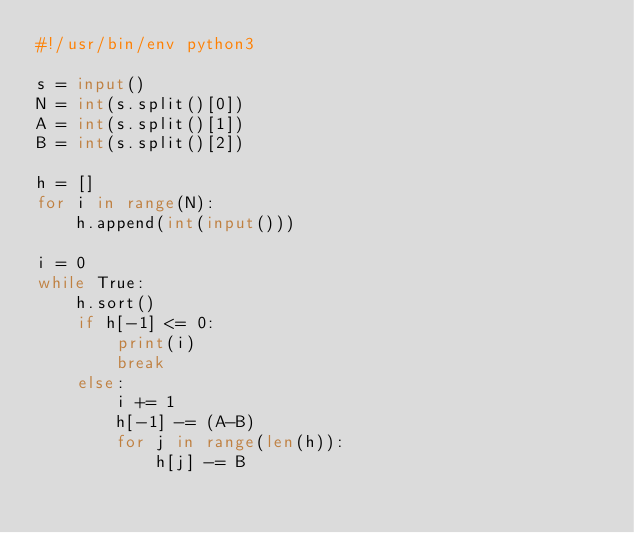<code> <loc_0><loc_0><loc_500><loc_500><_Python_>#!/usr/bin/env python3

s = input()
N = int(s.split()[0])
A = int(s.split()[1])
B = int(s.split()[2])

h = []
for i in range(N):
    h.append(int(input()))

i = 0
while True:
    h.sort()
    if h[-1] <= 0:
        print(i)
        break
    else:
        i += 1
        h[-1] -= (A-B)
        for j in range(len(h)):
            h[j] -= B</code> 